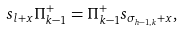<formula> <loc_0><loc_0><loc_500><loc_500>s _ { l + x } \Pi ^ { + } _ { k - 1 } = \Pi ^ { + } _ { k - 1 } s _ { \sigma _ { h - 1 , k } + x } ,</formula> 